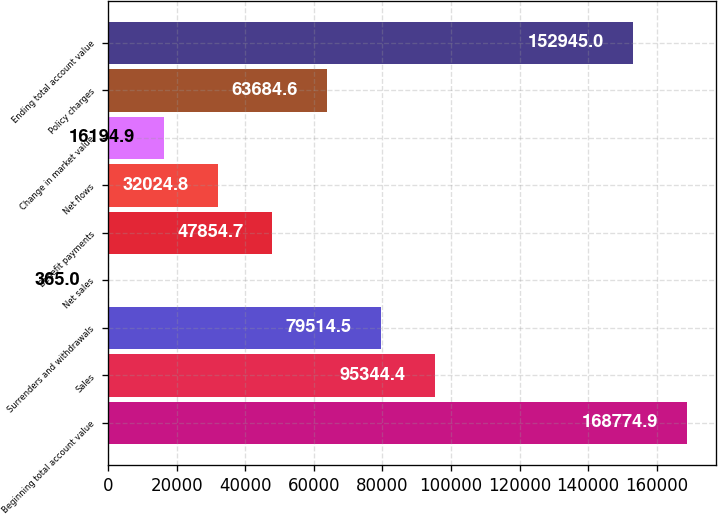<chart> <loc_0><loc_0><loc_500><loc_500><bar_chart><fcel>Beginning total account value<fcel>Sales<fcel>Surrenders and withdrawals<fcel>Net sales<fcel>Benefit payments<fcel>Net flows<fcel>Change in market value<fcel>Policy charges<fcel>Ending total account value<nl><fcel>168775<fcel>95344.4<fcel>79514.5<fcel>365<fcel>47854.7<fcel>32024.8<fcel>16194.9<fcel>63684.6<fcel>152945<nl></chart> 